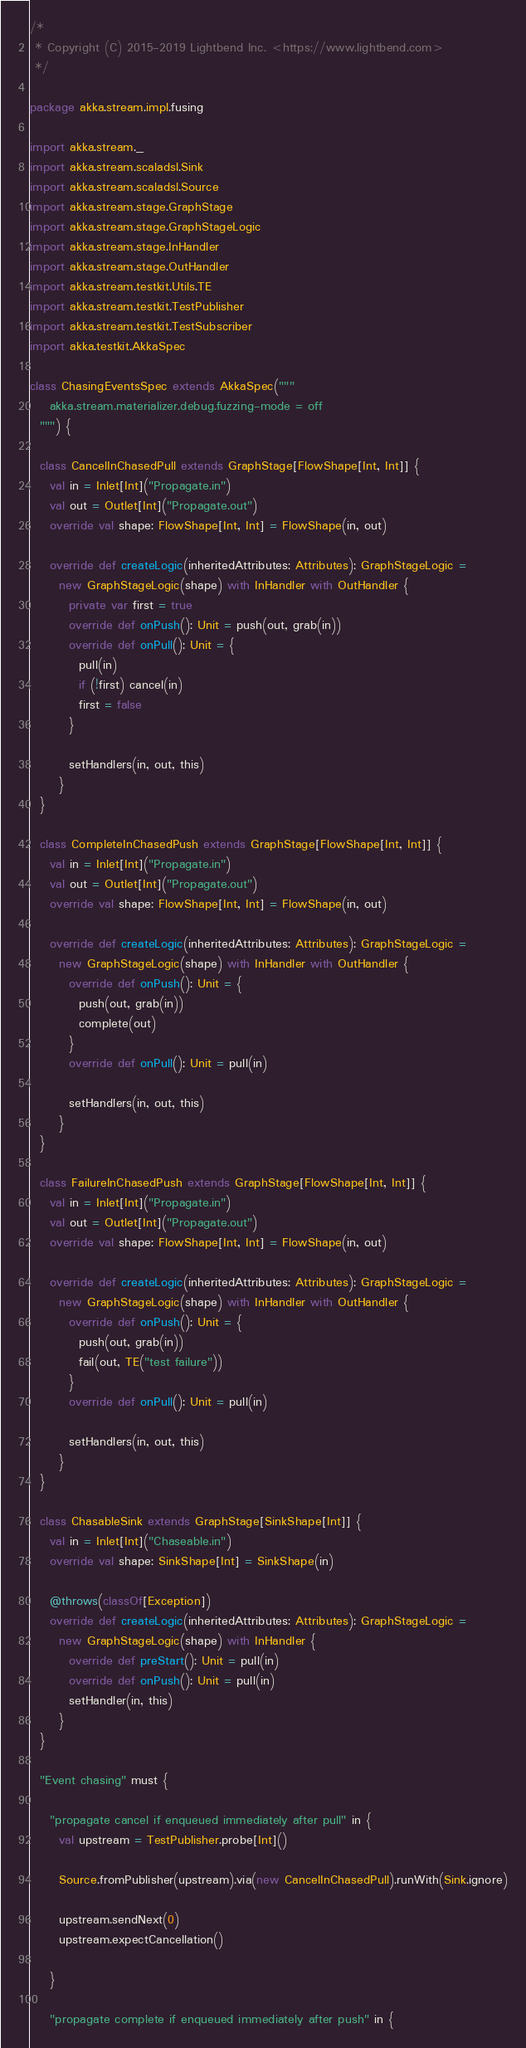Convert code to text. <code><loc_0><loc_0><loc_500><loc_500><_Scala_>/*
 * Copyright (C) 2015-2019 Lightbend Inc. <https://www.lightbend.com>
 */

package akka.stream.impl.fusing

import akka.stream._
import akka.stream.scaladsl.Sink
import akka.stream.scaladsl.Source
import akka.stream.stage.GraphStage
import akka.stream.stage.GraphStageLogic
import akka.stream.stage.InHandler
import akka.stream.stage.OutHandler
import akka.stream.testkit.Utils.TE
import akka.stream.testkit.TestPublisher
import akka.stream.testkit.TestSubscriber
import akka.testkit.AkkaSpec

class ChasingEventsSpec extends AkkaSpec("""
    akka.stream.materializer.debug.fuzzing-mode = off
  """) {

  class CancelInChasedPull extends GraphStage[FlowShape[Int, Int]] {
    val in = Inlet[Int]("Propagate.in")
    val out = Outlet[Int]("Propagate.out")
    override val shape: FlowShape[Int, Int] = FlowShape(in, out)

    override def createLogic(inheritedAttributes: Attributes): GraphStageLogic =
      new GraphStageLogic(shape) with InHandler with OutHandler {
        private var first = true
        override def onPush(): Unit = push(out, grab(in))
        override def onPull(): Unit = {
          pull(in)
          if (!first) cancel(in)
          first = false
        }

        setHandlers(in, out, this)
      }
  }

  class CompleteInChasedPush extends GraphStage[FlowShape[Int, Int]] {
    val in = Inlet[Int]("Propagate.in")
    val out = Outlet[Int]("Propagate.out")
    override val shape: FlowShape[Int, Int] = FlowShape(in, out)

    override def createLogic(inheritedAttributes: Attributes): GraphStageLogic =
      new GraphStageLogic(shape) with InHandler with OutHandler {
        override def onPush(): Unit = {
          push(out, grab(in))
          complete(out)
        }
        override def onPull(): Unit = pull(in)

        setHandlers(in, out, this)
      }
  }

  class FailureInChasedPush extends GraphStage[FlowShape[Int, Int]] {
    val in = Inlet[Int]("Propagate.in")
    val out = Outlet[Int]("Propagate.out")
    override val shape: FlowShape[Int, Int] = FlowShape(in, out)

    override def createLogic(inheritedAttributes: Attributes): GraphStageLogic =
      new GraphStageLogic(shape) with InHandler with OutHandler {
        override def onPush(): Unit = {
          push(out, grab(in))
          fail(out, TE("test failure"))
        }
        override def onPull(): Unit = pull(in)

        setHandlers(in, out, this)
      }
  }

  class ChasableSink extends GraphStage[SinkShape[Int]] {
    val in = Inlet[Int]("Chaseable.in")
    override val shape: SinkShape[Int] = SinkShape(in)

    @throws(classOf[Exception])
    override def createLogic(inheritedAttributes: Attributes): GraphStageLogic =
      new GraphStageLogic(shape) with InHandler {
        override def preStart(): Unit = pull(in)
        override def onPush(): Unit = pull(in)
        setHandler(in, this)
      }
  }

  "Event chasing" must {

    "propagate cancel if enqueued immediately after pull" in {
      val upstream = TestPublisher.probe[Int]()

      Source.fromPublisher(upstream).via(new CancelInChasedPull).runWith(Sink.ignore)

      upstream.sendNext(0)
      upstream.expectCancellation()

    }

    "propagate complete if enqueued immediately after push" in {</code> 